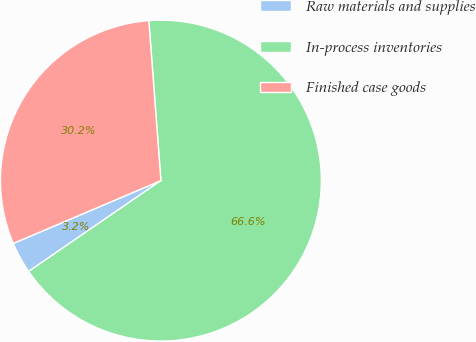Convert chart. <chart><loc_0><loc_0><loc_500><loc_500><pie_chart><fcel>Raw materials and supplies<fcel>In-process inventories<fcel>Finished case goods<nl><fcel>3.17%<fcel>66.63%<fcel>30.21%<nl></chart> 